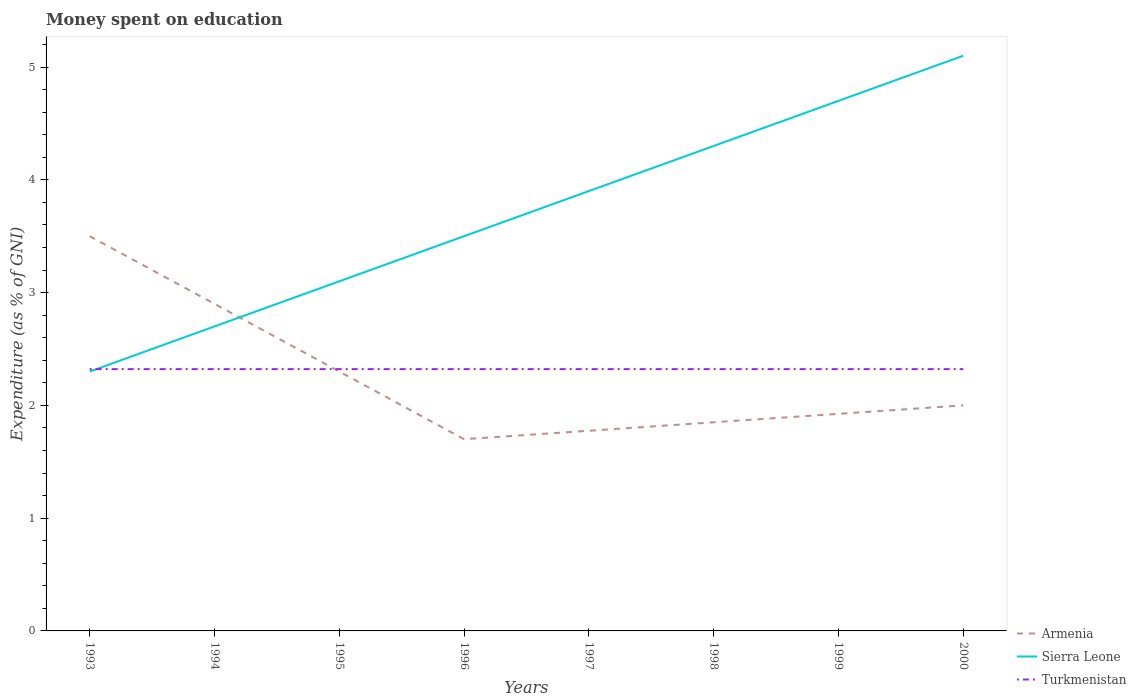How many different coloured lines are there?
Provide a short and direct response. 3. Does the line corresponding to Turkmenistan intersect with the line corresponding to Sierra Leone?
Your answer should be compact. Yes. Across all years, what is the maximum amount of money spent on education in Armenia?
Your response must be concise. 1.7. What is the total amount of money spent on education in Sierra Leone in the graph?
Ensure brevity in your answer.  -1.2. What is the difference between the highest and the second highest amount of money spent on education in Sierra Leone?
Ensure brevity in your answer.  2.8. What is the difference between the highest and the lowest amount of money spent on education in Turkmenistan?
Keep it short and to the point. 0. How many lines are there?
Keep it short and to the point. 3. What is the difference between two consecutive major ticks on the Y-axis?
Offer a terse response. 1. Are the values on the major ticks of Y-axis written in scientific E-notation?
Your answer should be compact. No. How many legend labels are there?
Make the answer very short. 3. What is the title of the graph?
Make the answer very short. Money spent on education. Does "United States" appear as one of the legend labels in the graph?
Provide a succinct answer. No. What is the label or title of the X-axis?
Offer a very short reply. Years. What is the label or title of the Y-axis?
Give a very brief answer. Expenditure (as % of GNI). What is the Expenditure (as % of GNI) in Armenia in 1993?
Your response must be concise. 3.5. What is the Expenditure (as % of GNI) in Sierra Leone in 1993?
Offer a terse response. 2.3. What is the Expenditure (as % of GNI) of Turkmenistan in 1993?
Your answer should be very brief. 2.32. What is the Expenditure (as % of GNI) in Armenia in 1994?
Give a very brief answer. 2.9. What is the Expenditure (as % of GNI) in Sierra Leone in 1994?
Give a very brief answer. 2.7. What is the Expenditure (as % of GNI) of Turkmenistan in 1994?
Your answer should be very brief. 2.32. What is the Expenditure (as % of GNI) in Armenia in 1995?
Provide a succinct answer. 2.3. What is the Expenditure (as % of GNI) of Sierra Leone in 1995?
Your answer should be very brief. 3.1. What is the Expenditure (as % of GNI) in Turkmenistan in 1995?
Your response must be concise. 2.32. What is the Expenditure (as % of GNI) of Armenia in 1996?
Offer a very short reply. 1.7. What is the Expenditure (as % of GNI) in Sierra Leone in 1996?
Provide a short and direct response. 3.5. What is the Expenditure (as % of GNI) of Turkmenistan in 1996?
Your answer should be compact. 2.32. What is the Expenditure (as % of GNI) of Armenia in 1997?
Offer a very short reply. 1.77. What is the Expenditure (as % of GNI) of Sierra Leone in 1997?
Give a very brief answer. 3.9. What is the Expenditure (as % of GNI) in Turkmenistan in 1997?
Give a very brief answer. 2.32. What is the Expenditure (as % of GNI) of Armenia in 1998?
Keep it short and to the point. 1.85. What is the Expenditure (as % of GNI) of Sierra Leone in 1998?
Keep it short and to the point. 4.3. What is the Expenditure (as % of GNI) in Turkmenistan in 1998?
Ensure brevity in your answer.  2.32. What is the Expenditure (as % of GNI) in Armenia in 1999?
Your response must be concise. 1.92. What is the Expenditure (as % of GNI) of Sierra Leone in 1999?
Make the answer very short. 4.7. What is the Expenditure (as % of GNI) of Turkmenistan in 1999?
Provide a short and direct response. 2.32. What is the Expenditure (as % of GNI) of Armenia in 2000?
Offer a terse response. 2. What is the Expenditure (as % of GNI) in Turkmenistan in 2000?
Keep it short and to the point. 2.32. Across all years, what is the maximum Expenditure (as % of GNI) in Turkmenistan?
Make the answer very short. 2.32. Across all years, what is the minimum Expenditure (as % of GNI) in Sierra Leone?
Provide a succinct answer. 2.3. Across all years, what is the minimum Expenditure (as % of GNI) of Turkmenistan?
Provide a short and direct response. 2.32. What is the total Expenditure (as % of GNI) of Armenia in the graph?
Offer a terse response. 17.95. What is the total Expenditure (as % of GNI) in Sierra Leone in the graph?
Ensure brevity in your answer.  29.6. What is the total Expenditure (as % of GNI) of Turkmenistan in the graph?
Offer a very short reply. 18.57. What is the difference between the Expenditure (as % of GNI) of Armenia in 1993 and that in 1995?
Keep it short and to the point. 1.2. What is the difference between the Expenditure (as % of GNI) in Turkmenistan in 1993 and that in 1995?
Offer a terse response. 0. What is the difference between the Expenditure (as % of GNI) of Armenia in 1993 and that in 1996?
Make the answer very short. 1.8. What is the difference between the Expenditure (as % of GNI) of Sierra Leone in 1993 and that in 1996?
Offer a very short reply. -1.2. What is the difference between the Expenditure (as % of GNI) of Armenia in 1993 and that in 1997?
Provide a short and direct response. 1.73. What is the difference between the Expenditure (as % of GNI) in Sierra Leone in 1993 and that in 1997?
Your answer should be compact. -1.6. What is the difference between the Expenditure (as % of GNI) in Armenia in 1993 and that in 1998?
Keep it short and to the point. 1.65. What is the difference between the Expenditure (as % of GNI) in Sierra Leone in 1993 and that in 1998?
Your answer should be compact. -2. What is the difference between the Expenditure (as % of GNI) of Armenia in 1993 and that in 1999?
Your response must be concise. 1.57. What is the difference between the Expenditure (as % of GNI) of Turkmenistan in 1993 and that in 1999?
Give a very brief answer. 0. What is the difference between the Expenditure (as % of GNI) of Sierra Leone in 1993 and that in 2000?
Your answer should be very brief. -2.8. What is the difference between the Expenditure (as % of GNI) of Armenia in 1994 and that in 1995?
Offer a terse response. 0.6. What is the difference between the Expenditure (as % of GNI) in Sierra Leone in 1994 and that in 1995?
Your response must be concise. -0.4. What is the difference between the Expenditure (as % of GNI) of Armenia in 1994 and that in 1996?
Provide a short and direct response. 1.2. What is the difference between the Expenditure (as % of GNI) of Turkmenistan in 1994 and that in 1997?
Your answer should be compact. 0. What is the difference between the Expenditure (as % of GNI) of Turkmenistan in 1994 and that in 1998?
Make the answer very short. 0. What is the difference between the Expenditure (as % of GNI) in Armenia in 1994 and that in 1999?
Offer a terse response. 0.97. What is the difference between the Expenditure (as % of GNI) of Armenia in 1994 and that in 2000?
Your answer should be compact. 0.9. What is the difference between the Expenditure (as % of GNI) of Sierra Leone in 1994 and that in 2000?
Offer a very short reply. -2.4. What is the difference between the Expenditure (as % of GNI) in Turkmenistan in 1994 and that in 2000?
Provide a succinct answer. 0. What is the difference between the Expenditure (as % of GNI) of Armenia in 1995 and that in 1996?
Ensure brevity in your answer.  0.6. What is the difference between the Expenditure (as % of GNI) in Turkmenistan in 1995 and that in 1996?
Your response must be concise. 0. What is the difference between the Expenditure (as % of GNI) of Armenia in 1995 and that in 1997?
Offer a terse response. 0.53. What is the difference between the Expenditure (as % of GNI) of Sierra Leone in 1995 and that in 1997?
Make the answer very short. -0.8. What is the difference between the Expenditure (as % of GNI) in Armenia in 1995 and that in 1998?
Keep it short and to the point. 0.45. What is the difference between the Expenditure (as % of GNI) in Sierra Leone in 1995 and that in 1998?
Offer a terse response. -1.2. What is the difference between the Expenditure (as % of GNI) in Armenia in 1995 and that in 1999?
Provide a short and direct response. 0.38. What is the difference between the Expenditure (as % of GNI) of Sierra Leone in 1995 and that in 2000?
Your response must be concise. -2. What is the difference between the Expenditure (as % of GNI) in Turkmenistan in 1995 and that in 2000?
Your response must be concise. 0. What is the difference between the Expenditure (as % of GNI) in Armenia in 1996 and that in 1997?
Your answer should be compact. -0.07. What is the difference between the Expenditure (as % of GNI) of Turkmenistan in 1996 and that in 1997?
Your answer should be compact. 0. What is the difference between the Expenditure (as % of GNI) of Armenia in 1996 and that in 1998?
Provide a short and direct response. -0.15. What is the difference between the Expenditure (as % of GNI) in Sierra Leone in 1996 and that in 1998?
Keep it short and to the point. -0.8. What is the difference between the Expenditure (as % of GNI) of Turkmenistan in 1996 and that in 1998?
Ensure brevity in your answer.  0. What is the difference between the Expenditure (as % of GNI) of Armenia in 1996 and that in 1999?
Make the answer very short. -0.23. What is the difference between the Expenditure (as % of GNI) in Turkmenistan in 1996 and that in 2000?
Offer a terse response. 0. What is the difference between the Expenditure (as % of GNI) in Armenia in 1997 and that in 1998?
Offer a very short reply. -0.07. What is the difference between the Expenditure (as % of GNI) in Sierra Leone in 1997 and that in 1998?
Ensure brevity in your answer.  -0.4. What is the difference between the Expenditure (as % of GNI) of Turkmenistan in 1997 and that in 1998?
Your answer should be very brief. 0. What is the difference between the Expenditure (as % of GNI) in Armenia in 1997 and that in 1999?
Your answer should be compact. -0.15. What is the difference between the Expenditure (as % of GNI) in Sierra Leone in 1997 and that in 1999?
Ensure brevity in your answer.  -0.8. What is the difference between the Expenditure (as % of GNI) in Armenia in 1997 and that in 2000?
Offer a terse response. -0.23. What is the difference between the Expenditure (as % of GNI) in Turkmenistan in 1997 and that in 2000?
Your answer should be very brief. 0. What is the difference between the Expenditure (as % of GNI) of Armenia in 1998 and that in 1999?
Your answer should be compact. -0.07. What is the difference between the Expenditure (as % of GNI) in Sierra Leone in 1998 and that in 1999?
Your response must be concise. -0.4. What is the difference between the Expenditure (as % of GNI) of Turkmenistan in 1998 and that in 1999?
Your answer should be very brief. 0. What is the difference between the Expenditure (as % of GNI) of Armenia in 1998 and that in 2000?
Provide a succinct answer. -0.15. What is the difference between the Expenditure (as % of GNI) in Sierra Leone in 1998 and that in 2000?
Give a very brief answer. -0.8. What is the difference between the Expenditure (as % of GNI) in Armenia in 1999 and that in 2000?
Provide a succinct answer. -0.07. What is the difference between the Expenditure (as % of GNI) of Sierra Leone in 1999 and that in 2000?
Keep it short and to the point. -0.4. What is the difference between the Expenditure (as % of GNI) of Armenia in 1993 and the Expenditure (as % of GNI) of Sierra Leone in 1994?
Provide a succinct answer. 0.8. What is the difference between the Expenditure (as % of GNI) in Armenia in 1993 and the Expenditure (as % of GNI) in Turkmenistan in 1994?
Provide a short and direct response. 1.18. What is the difference between the Expenditure (as % of GNI) in Sierra Leone in 1993 and the Expenditure (as % of GNI) in Turkmenistan in 1994?
Give a very brief answer. -0.02. What is the difference between the Expenditure (as % of GNI) in Armenia in 1993 and the Expenditure (as % of GNI) in Sierra Leone in 1995?
Ensure brevity in your answer.  0.4. What is the difference between the Expenditure (as % of GNI) in Armenia in 1993 and the Expenditure (as % of GNI) in Turkmenistan in 1995?
Your answer should be very brief. 1.18. What is the difference between the Expenditure (as % of GNI) of Sierra Leone in 1993 and the Expenditure (as % of GNI) of Turkmenistan in 1995?
Make the answer very short. -0.02. What is the difference between the Expenditure (as % of GNI) of Armenia in 1993 and the Expenditure (as % of GNI) of Turkmenistan in 1996?
Make the answer very short. 1.18. What is the difference between the Expenditure (as % of GNI) of Sierra Leone in 1993 and the Expenditure (as % of GNI) of Turkmenistan in 1996?
Make the answer very short. -0.02. What is the difference between the Expenditure (as % of GNI) in Armenia in 1993 and the Expenditure (as % of GNI) in Sierra Leone in 1997?
Make the answer very short. -0.4. What is the difference between the Expenditure (as % of GNI) in Armenia in 1993 and the Expenditure (as % of GNI) in Turkmenistan in 1997?
Offer a terse response. 1.18. What is the difference between the Expenditure (as % of GNI) in Sierra Leone in 1993 and the Expenditure (as % of GNI) in Turkmenistan in 1997?
Offer a terse response. -0.02. What is the difference between the Expenditure (as % of GNI) in Armenia in 1993 and the Expenditure (as % of GNI) in Turkmenistan in 1998?
Provide a short and direct response. 1.18. What is the difference between the Expenditure (as % of GNI) of Sierra Leone in 1993 and the Expenditure (as % of GNI) of Turkmenistan in 1998?
Give a very brief answer. -0.02. What is the difference between the Expenditure (as % of GNI) in Armenia in 1993 and the Expenditure (as % of GNI) in Turkmenistan in 1999?
Your response must be concise. 1.18. What is the difference between the Expenditure (as % of GNI) of Sierra Leone in 1993 and the Expenditure (as % of GNI) of Turkmenistan in 1999?
Ensure brevity in your answer.  -0.02. What is the difference between the Expenditure (as % of GNI) in Armenia in 1993 and the Expenditure (as % of GNI) in Turkmenistan in 2000?
Provide a succinct answer. 1.18. What is the difference between the Expenditure (as % of GNI) of Sierra Leone in 1993 and the Expenditure (as % of GNI) of Turkmenistan in 2000?
Provide a succinct answer. -0.02. What is the difference between the Expenditure (as % of GNI) of Armenia in 1994 and the Expenditure (as % of GNI) of Sierra Leone in 1995?
Offer a terse response. -0.2. What is the difference between the Expenditure (as % of GNI) in Armenia in 1994 and the Expenditure (as % of GNI) in Turkmenistan in 1995?
Your response must be concise. 0.58. What is the difference between the Expenditure (as % of GNI) in Sierra Leone in 1994 and the Expenditure (as % of GNI) in Turkmenistan in 1995?
Your answer should be compact. 0.38. What is the difference between the Expenditure (as % of GNI) in Armenia in 1994 and the Expenditure (as % of GNI) in Sierra Leone in 1996?
Offer a very short reply. -0.6. What is the difference between the Expenditure (as % of GNI) in Armenia in 1994 and the Expenditure (as % of GNI) in Turkmenistan in 1996?
Provide a succinct answer. 0.58. What is the difference between the Expenditure (as % of GNI) of Sierra Leone in 1994 and the Expenditure (as % of GNI) of Turkmenistan in 1996?
Your response must be concise. 0.38. What is the difference between the Expenditure (as % of GNI) of Armenia in 1994 and the Expenditure (as % of GNI) of Turkmenistan in 1997?
Offer a very short reply. 0.58. What is the difference between the Expenditure (as % of GNI) of Sierra Leone in 1994 and the Expenditure (as % of GNI) of Turkmenistan in 1997?
Offer a terse response. 0.38. What is the difference between the Expenditure (as % of GNI) in Armenia in 1994 and the Expenditure (as % of GNI) in Turkmenistan in 1998?
Provide a short and direct response. 0.58. What is the difference between the Expenditure (as % of GNI) in Sierra Leone in 1994 and the Expenditure (as % of GNI) in Turkmenistan in 1998?
Your answer should be compact. 0.38. What is the difference between the Expenditure (as % of GNI) of Armenia in 1994 and the Expenditure (as % of GNI) of Turkmenistan in 1999?
Your answer should be very brief. 0.58. What is the difference between the Expenditure (as % of GNI) of Sierra Leone in 1994 and the Expenditure (as % of GNI) of Turkmenistan in 1999?
Offer a terse response. 0.38. What is the difference between the Expenditure (as % of GNI) of Armenia in 1994 and the Expenditure (as % of GNI) of Turkmenistan in 2000?
Offer a very short reply. 0.58. What is the difference between the Expenditure (as % of GNI) of Sierra Leone in 1994 and the Expenditure (as % of GNI) of Turkmenistan in 2000?
Your answer should be compact. 0.38. What is the difference between the Expenditure (as % of GNI) of Armenia in 1995 and the Expenditure (as % of GNI) of Sierra Leone in 1996?
Your answer should be compact. -1.2. What is the difference between the Expenditure (as % of GNI) in Armenia in 1995 and the Expenditure (as % of GNI) in Turkmenistan in 1996?
Your answer should be very brief. -0.02. What is the difference between the Expenditure (as % of GNI) in Sierra Leone in 1995 and the Expenditure (as % of GNI) in Turkmenistan in 1996?
Offer a very short reply. 0.78. What is the difference between the Expenditure (as % of GNI) of Armenia in 1995 and the Expenditure (as % of GNI) of Turkmenistan in 1997?
Ensure brevity in your answer.  -0.02. What is the difference between the Expenditure (as % of GNI) in Sierra Leone in 1995 and the Expenditure (as % of GNI) in Turkmenistan in 1997?
Your response must be concise. 0.78. What is the difference between the Expenditure (as % of GNI) of Armenia in 1995 and the Expenditure (as % of GNI) of Turkmenistan in 1998?
Give a very brief answer. -0.02. What is the difference between the Expenditure (as % of GNI) in Sierra Leone in 1995 and the Expenditure (as % of GNI) in Turkmenistan in 1998?
Give a very brief answer. 0.78. What is the difference between the Expenditure (as % of GNI) of Armenia in 1995 and the Expenditure (as % of GNI) of Sierra Leone in 1999?
Provide a short and direct response. -2.4. What is the difference between the Expenditure (as % of GNI) in Armenia in 1995 and the Expenditure (as % of GNI) in Turkmenistan in 1999?
Provide a short and direct response. -0.02. What is the difference between the Expenditure (as % of GNI) in Sierra Leone in 1995 and the Expenditure (as % of GNI) in Turkmenistan in 1999?
Ensure brevity in your answer.  0.78. What is the difference between the Expenditure (as % of GNI) in Armenia in 1995 and the Expenditure (as % of GNI) in Sierra Leone in 2000?
Provide a succinct answer. -2.8. What is the difference between the Expenditure (as % of GNI) of Armenia in 1995 and the Expenditure (as % of GNI) of Turkmenistan in 2000?
Ensure brevity in your answer.  -0.02. What is the difference between the Expenditure (as % of GNI) of Sierra Leone in 1995 and the Expenditure (as % of GNI) of Turkmenistan in 2000?
Your response must be concise. 0.78. What is the difference between the Expenditure (as % of GNI) of Armenia in 1996 and the Expenditure (as % of GNI) of Turkmenistan in 1997?
Your response must be concise. -0.62. What is the difference between the Expenditure (as % of GNI) of Sierra Leone in 1996 and the Expenditure (as % of GNI) of Turkmenistan in 1997?
Offer a terse response. 1.18. What is the difference between the Expenditure (as % of GNI) in Armenia in 1996 and the Expenditure (as % of GNI) in Sierra Leone in 1998?
Your response must be concise. -2.6. What is the difference between the Expenditure (as % of GNI) of Armenia in 1996 and the Expenditure (as % of GNI) of Turkmenistan in 1998?
Your answer should be very brief. -0.62. What is the difference between the Expenditure (as % of GNI) in Sierra Leone in 1996 and the Expenditure (as % of GNI) in Turkmenistan in 1998?
Offer a terse response. 1.18. What is the difference between the Expenditure (as % of GNI) in Armenia in 1996 and the Expenditure (as % of GNI) in Turkmenistan in 1999?
Offer a very short reply. -0.62. What is the difference between the Expenditure (as % of GNI) in Sierra Leone in 1996 and the Expenditure (as % of GNI) in Turkmenistan in 1999?
Ensure brevity in your answer.  1.18. What is the difference between the Expenditure (as % of GNI) of Armenia in 1996 and the Expenditure (as % of GNI) of Turkmenistan in 2000?
Your answer should be very brief. -0.62. What is the difference between the Expenditure (as % of GNI) of Sierra Leone in 1996 and the Expenditure (as % of GNI) of Turkmenistan in 2000?
Keep it short and to the point. 1.18. What is the difference between the Expenditure (as % of GNI) of Armenia in 1997 and the Expenditure (as % of GNI) of Sierra Leone in 1998?
Offer a very short reply. -2.52. What is the difference between the Expenditure (as % of GNI) in Armenia in 1997 and the Expenditure (as % of GNI) in Turkmenistan in 1998?
Your response must be concise. -0.55. What is the difference between the Expenditure (as % of GNI) in Sierra Leone in 1997 and the Expenditure (as % of GNI) in Turkmenistan in 1998?
Provide a short and direct response. 1.58. What is the difference between the Expenditure (as % of GNI) in Armenia in 1997 and the Expenditure (as % of GNI) in Sierra Leone in 1999?
Provide a short and direct response. -2.92. What is the difference between the Expenditure (as % of GNI) in Armenia in 1997 and the Expenditure (as % of GNI) in Turkmenistan in 1999?
Give a very brief answer. -0.55. What is the difference between the Expenditure (as % of GNI) in Sierra Leone in 1997 and the Expenditure (as % of GNI) in Turkmenistan in 1999?
Make the answer very short. 1.58. What is the difference between the Expenditure (as % of GNI) of Armenia in 1997 and the Expenditure (as % of GNI) of Sierra Leone in 2000?
Ensure brevity in your answer.  -3.33. What is the difference between the Expenditure (as % of GNI) in Armenia in 1997 and the Expenditure (as % of GNI) in Turkmenistan in 2000?
Provide a succinct answer. -0.55. What is the difference between the Expenditure (as % of GNI) in Sierra Leone in 1997 and the Expenditure (as % of GNI) in Turkmenistan in 2000?
Provide a succinct answer. 1.58. What is the difference between the Expenditure (as % of GNI) of Armenia in 1998 and the Expenditure (as % of GNI) of Sierra Leone in 1999?
Give a very brief answer. -2.85. What is the difference between the Expenditure (as % of GNI) of Armenia in 1998 and the Expenditure (as % of GNI) of Turkmenistan in 1999?
Offer a very short reply. -0.47. What is the difference between the Expenditure (as % of GNI) in Sierra Leone in 1998 and the Expenditure (as % of GNI) in Turkmenistan in 1999?
Keep it short and to the point. 1.98. What is the difference between the Expenditure (as % of GNI) of Armenia in 1998 and the Expenditure (as % of GNI) of Sierra Leone in 2000?
Your answer should be very brief. -3.25. What is the difference between the Expenditure (as % of GNI) of Armenia in 1998 and the Expenditure (as % of GNI) of Turkmenistan in 2000?
Ensure brevity in your answer.  -0.47. What is the difference between the Expenditure (as % of GNI) in Sierra Leone in 1998 and the Expenditure (as % of GNI) in Turkmenistan in 2000?
Make the answer very short. 1.98. What is the difference between the Expenditure (as % of GNI) in Armenia in 1999 and the Expenditure (as % of GNI) in Sierra Leone in 2000?
Your answer should be compact. -3.17. What is the difference between the Expenditure (as % of GNI) of Armenia in 1999 and the Expenditure (as % of GNI) of Turkmenistan in 2000?
Provide a succinct answer. -0.4. What is the difference between the Expenditure (as % of GNI) in Sierra Leone in 1999 and the Expenditure (as % of GNI) in Turkmenistan in 2000?
Give a very brief answer. 2.38. What is the average Expenditure (as % of GNI) in Armenia per year?
Your response must be concise. 2.24. What is the average Expenditure (as % of GNI) of Sierra Leone per year?
Provide a succinct answer. 3.7. What is the average Expenditure (as % of GNI) in Turkmenistan per year?
Provide a succinct answer. 2.32. In the year 1993, what is the difference between the Expenditure (as % of GNI) of Armenia and Expenditure (as % of GNI) of Turkmenistan?
Your response must be concise. 1.18. In the year 1993, what is the difference between the Expenditure (as % of GNI) of Sierra Leone and Expenditure (as % of GNI) of Turkmenistan?
Your response must be concise. -0.02. In the year 1994, what is the difference between the Expenditure (as % of GNI) in Armenia and Expenditure (as % of GNI) in Turkmenistan?
Provide a succinct answer. 0.58. In the year 1994, what is the difference between the Expenditure (as % of GNI) in Sierra Leone and Expenditure (as % of GNI) in Turkmenistan?
Your response must be concise. 0.38. In the year 1995, what is the difference between the Expenditure (as % of GNI) in Armenia and Expenditure (as % of GNI) in Turkmenistan?
Your answer should be very brief. -0.02. In the year 1995, what is the difference between the Expenditure (as % of GNI) of Sierra Leone and Expenditure (as % of GNI) of Turkmenistan?
Provide a succinct answer. 0.78. In the year 1996, what is the difference between the Expenditure (as % of GNI) in Armenia and Expenditure (as % of GNI) in Sierra Leone?
Offer a terse response. -1.8. In the year 1996, what is the difference between the Expenditure (as % of GNI) in Armenia and Expenditure (as % of GNI) in Turkmenistan?
Provide a short and direct response. -0.62. In the year 1996, what is the difference between the Expenditure (as % of GNI) of Sierra Leone and Expenditure (as % of GNI) of Turkmenistan?
Provide a short and direct response. 1.18. In the year 1997, what is the difference between the Expenditure (as % of GNI) of Armenia and Expenditure (as % of GNI) of Sierra Leone?
Provide a short and direct response. -2.12. In the year 1997, what is the difference between the Expenditure (as % of GNI) of Armenia and Expenditure (as % of GNI) of Turkmenistan?
Provide a short and direct response. -0.55. In the year 1997, what is the difference between the Expenditure (as % of GNI) in Sierra Leone and Expenditure (as % of GNI) in Turkmenistan?
Your answer should be very brief. 1.58. In the year 1998, what is the difference between the Expenditure (as % of GNI) of Armenia and Expenditure (as % of GNI) of Sierra Leone?
Keep it short and to the point. -2.45. In the year 1998, what is the difference between the Expenditure (as % of GNI) in Armenia and Expenditure (as % of GNI) in Turkmenistan?
Your answer should be compact. -0.47. In the year 1998, what is the difference between the Expenditure (as % of GNI) in Sierra Leone and Expenditure (as % of GNI) in Turkmenistan?
Offer a terse response. 1.98. In the year 1999, what is the difference between the Expenditure (as % of GNI) of Armenia and Expenditure (as % of GNI) of Sierra Leone?
Make the answer very short. -2.77. In the year 1999, what is the difference between the Expenditure (as % of GNI) in Armenia and Expenditure (as % of GNI) in Turkmenistan?
Your answer should be very brief. -0.4. In the year 1999, what is the difference between the Expenditure (as % of GNI) of Sierra Leone and Expenditure (as % of GNI) of Turkmenistan?
Your answer should be very brief. 2.38. In the year 2000, what is the difference between the Expenditure (as % of GNI) in Armenia and Expenditure (as % of GNI) in Turkmenistan?
Keep it short and to the point. -0.32. In the year 2000, what is the difference between the Expenditure (as % of GNI) in Sierra Leone and Expenditure (as % of GNI) in Turkmenistan?
Make the answer very short. 2.78. What is the ratio of the Expenditure (as % of GNI) of Armenia in 1993 to that in 1994?
Keep it short and to the point. 1.21. What is the ratio of the Expenditure (as % of GNI) in Sierra Leone in 1993 to that in 1994?
Provide a short and direct response. 0.85. What is the ratio of the Expenditure (as % of GNI) in Armenia in 1993 to that in 1995?
Provide a succinct answer. 1.52. What is the ratio of the Expenditure (as % of GNI) of Sierra Leone in 1993 to that in 1995?
Offer a very short reply. 0.74. What is the ratio of the Expenditure (as % of GNI) of Turkmenistan in 1993 to that in 1995?
Give a very brief answer. 1. What is the ratio of the Expenditure (as % of GNI) in Armenia in 1993 to that in 1996?
Offer a terse response. 2.06. What is the ratio of the Expenditure (as % of GNI) of Sierra Leone in 1993 to that in 1996?
Keep it short and to the point. 0.66. What is the ratio of the Expenditure (as % of GNI) of Armenia in 1993 to that in 1997?
Your answer should be compact. 1.97. What is the ratio of the Expenditure (as % of GNI) of Sierra Leone in 1993 to that in 1997?
Provide a succinct answer. 0.59. What is the ratio of the Expenditure (as % of GNI) in Armenia in 1993 to that in 1998?
Offer a terse response. 1.89. What is the ratio of the Expenditure (as % of GNI) in Sierra Leone in 1993 to that in 1998?
Keep it short and to the point. 0.53. What is the ratio of the Expenditure (as % of GNI) of Turkmenistan in 1993 to that in 1998?
Your response must be concise. 1. What is the ratio of the Expenditure (as % of GNI) in Armenia in 1993 to that in 1999?
Make the answer very short. 1.82. What is the ratio of the Expenditure (as % of GNI) of Sierra Leone in 1993 to that in 1999?
Make the answer very short. 0.49. What is the ratio of the Expenditure (as % of GNI) in Turkmenistan in 1993 to that in 1999?
Provide a succinct answer. 1. What is the ratio of the Expenditure (as % of GNI) of Sierra Leone in 1993 to that in 2000?
Offer a very short reply. 0.45. What is the ratio of the Expenditure (as % of GNI) of Armenia in 1994 to that in 1995?
Ensure brevity in your answer.  1.26. What is the ratio of the Expenditure (as % of GNI) in Sierra Leone in 1994 to that in 1995?
Offer a very short reply. 0.87. What is the ratio of the Expenditure (as % of GNI) of Turkmenistan in 1994 to that in 1995?
Ensure brevity in your answer.  1. What is the ratio of the Expenditure (as % of GNI) in Armenia in 1994 to that in 1996?
Make the answer very short. 1.71. What is the ratio of the Expenditure (as % of GNI) in Sierra Leone in 1994 to that in 1996?
Your response must be concise. 0.77. What is the ratio of the Expenditure (as % of GNI) of Turkmenistan in 1994 to that in 1996?
Keep it short and to the point. 1. What is the ratio of the Expenditure (as % of GNI) of Armenia in 1994 to that in 1997?
Your answer should be very brief. 1.63. What is the ratio of the Expenditure (as % of GNI) in Sierra Leone in 1994 to that in 1997?
Your answer should be very brief. 0.69. What is the ratio of the Expenditure (as % of GNI) in Turkmenistan in 1994 to that in 1997?
Provide a short and direct response. 1. What is the ratio of the Expenditure (as % of GNI) of Armenia in 1994 to that in 1998?
Your answer should be very brief. 1.57. What is the ratio of the Expenditure (as % of GNI) of Sierra Leone in 1994 to that in 1998?
Offer a terse response. 0.63. What is the ratio of the Expenditure (as % of GNI) in Armenia in 1994 to that in 1999?
Provide a succinct answer. 1.51. What is the ratio of the Expenditure (as % of GNI) in Sierra Leone in 1994 to that in 1999?
Offer a very short reply. 0.57. What is the ratio of the Expenditure (as % of GNI) of Turkmenistan in 1994 to that in 1999?
Your answer should be compact. 1. What is the ratio of the Expenditure (as % of GNI) of Armenia in 1994 to that in 2000?
Give a very brief answer. 1.45. What is the ratio of the Expenditure (as % of GNI) in Sierra Leone in 1994 to that in 2000?
Ensure brevity in your answer.  0.53. What is the ratio of the Expenditure (as % of GNI) of Armenia in 1995 to that in 1996?
Give a very brief answer. 1.35. What is the ratio of the Expenditure (as % of GNI) of Sierra Leone in 1995 to that in 1996?
Your answer should be compact. 0.89. What is the ratio of the Expenditure (as % of GNI) in Armenia in 1995 to that in 1997?
Provide a succinct answer. 1.3. What is the ratio of the Expenditure (as % of GNI) in Sierra Leone in 1995 to that in 1997?
Provide a succinct answer. 0.79. What is the ratio of the Expenditure (as % of GNI) in Turkmenistan in 1995 to that in 1997?
Your answer should be compact. 1. What is the ratio of the Expenditure (as % of GNI) of Armenia in 1995 to that in 1998?
Give a very brief answer. 1.24. What is the ratio of the Expenditure (as % of GNI) of Sierra Leone in 1995 to that in 1998?
Your answer should be compact. 0.72. What is the ratio of the Expenditure (as % of GNI) in Armenia in 1995 to that in 1999?
Ensure brevity in your answer.  1.19. What is the ratio of the Expenditure (as % of GNI) of Sierra Leone in 1995 to that in 1999?
Keep it short and to the point. 0.66. What is the ratio of the Expenditure (as % of GNI) in Turkmenistan in 1995 to that in 1999?
Your response must be concise. 1. What is the ratio of the Expenditure (as % of GNI) in Armenia in 1995 to that in 2000?
Your answer should be compact. 1.15. What is the ratio of the Expenditure (as % of GNI) in Sierra Leone in 1995 to that in 2000?
Keep it short and to the point. 0.61. What is the ratio of the Expenditure (as % of GNI) of Armenia in 1996 to that in 1997?
Your response must be concise. 0.96. What is the ratio of the Expenditure (as % of GNI) in Sierra Leone in 1996 to that in 1997?
Offer a terse response. 0.9. What is the ratio of the Expenditure (as % of GNI) of Armenia in 1996 to that in 1998?
Your response must be concise. 0.92. What is the ratio of the Expenditure (as % of GNI) of Sierra Leone in 1996 to that in 1998?
Ensure brevity in your answer.  0.81. What is the ratio of the Expenditure (as % of GNI) in Turkmenistan in 1996 to that in 1998?
Keep it short and to the point. 1. What is the ratio of the Expenditure (as % of GNI) in Armenia in 1996 to that in 1999?
Your answer should be very brief. 0.88. What is the ratio of the Expenditure (as % of GNI) in Sierra Leone in 1996 to that in 1999?
Offer a terse response. 0.74. What is the ratio of the Expenditure (as % of GNI) in Turkmenistan in 1996 to that in 1999?
Offer a very short reply. 1. What is the ratio of the Expenditure (as % of GNI) in Sierra Leone in 1996 to that in 2000?
Your response must be concise. 0.69. What is the ratio of the Expenditure (as % of GNI) in Armenia in 1997 to that in 1998?
Ensure brevity in your answer.  0.96. What is the ratio of the Expenditure (as % of GNI) of Sierra Leone in 1997 to that in 1998?
Your answer should be compact. 0.91. What is the ratio of the Expenditure (as % of GNI) of Armenia in 1997 to that in 1999?
Give a very brief answer. 0.92. What is the ratio of the Expenditure (as % of GNI) of Sierra Leone in 1997 to that in 1999?
Your response must be concise. 0.83. What is the ratio of the Expenditure (as % of GNI) in Armenia in 1997 to that in 2000?
Offer a very short reply. 0.89. What is the ratio of the Expenditure (as % of GNI) of Sierra Leone in 1997 to that in 2000?
Your response must be concise. 0.76. What is the ratio of the Expenditure (as % of GNI) in Sierra Leone in 1998 to that in 1999?
Offer a very short reply. 0.91. What is the ratio of the Expenditure (as % of GNI) in Armenia in 1998 to that in 2000?
Ensure brevity in your answer.  0.93. What is the ratio of the Expenditure (as % of GNI) in Sierra Leone in 1998 to that in 2000?
Keep it short and to the point. 0.84. What is the ratio of the Expenditure (as % of GNI) of Turkmenistan in 1998 to that in 2000?
Provide a succinct answer. 1. What is the ratio of the Expenditure (as % of GNI) of Armenia in 1999 to that in 2000?
Offer a terse response. 0.96. What is the ratio of the Expenditure (as % of GNI) of Sierra Leone in 1999 to that in 2000?
Ensure brevity in your answer.  0.92. What is the difference between the highest and the second highest Expenditure (as % of GNI) in Armenia?
Offer a very short reply. 0.6. What is the difference between the highest and the second highest Expenditure (as % of GNI) in Turkmenistan?
Your answer should be compact. 0. What is the difference between the highest and the lowest Expenditure (as % of GNI) of Sierra Leone?
Your answer should be compact. 2.8. What is the difference between the highest and the lowest Expenditure (as % of GNI) of Turkmenistan?
Provide a succinct answer. 0. 